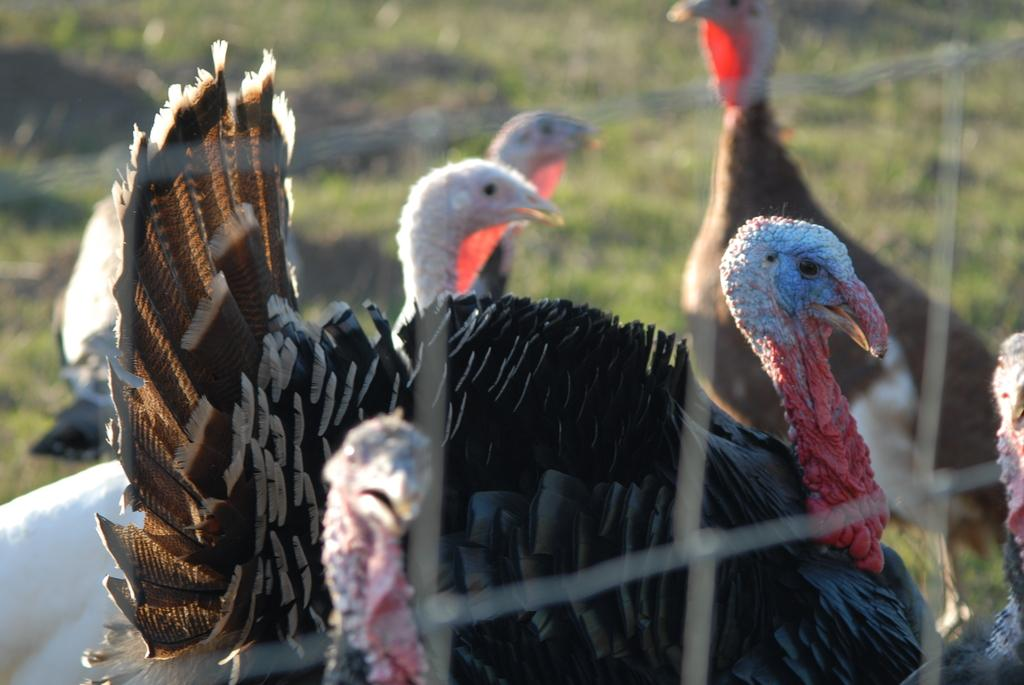What is the main structure visible in the image? There is a mesh in the image. What animals are behind the mesh? There are turkeys behind the mesh. What type of surface is visible at the bottom of the image? There is grass on the surface at the bottom of the image. Can you see any fairies dancing among the turkeys in the image? There are no fairies present in the image; it only features a mesh, turkeys, and grass. What type of rose can be seen growing near the turkeys in the image? There are no roses present in the image; it only features a mesh, turkeys, and grass. 